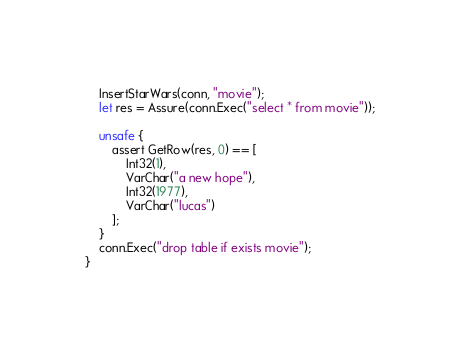<code> <loc_0><loc_0><loc_500><loc_500><_Rust_>    InsertStarWars(conn, "movie");
    let res = Assure(conn.Exec("select * from movie"));

    unsafe {
        assert GetRow(res, 0) == [
            Int32(1), 
            VarChar("a new hope"), 
            Int32(1977), 
            VarChar("lucas")
        ];
    }
    conn.Exec("drop table if exists movie");
}
</code> 